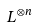<formula> <loc_0><loc_0><loc_500><loc_500>L ^ { \otimes n }</formula> 